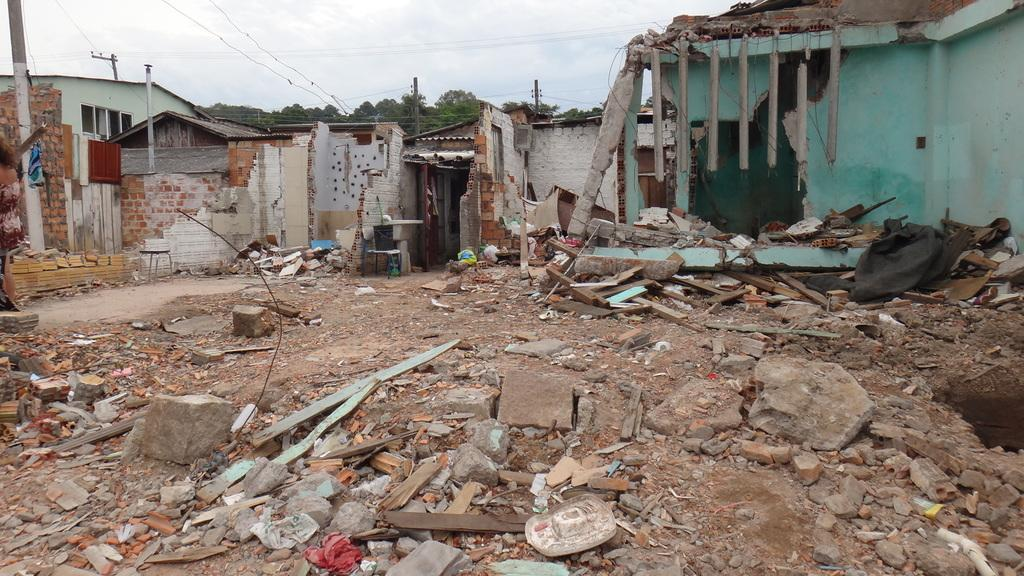What type of structures can be seen in the image? There are houses in the image. What other objects can be seen in the image besides houses? There are poles, trees, objects, a stool, stones, and wooden sticks in the image. Can you describe the natural elements present in the image? There are trees and stones in the image. What is visible at the top of the image? The sky is visible at the top of the image. What type of ray is emitting light from the stool in the image? There is no ray emitting light from the stool in the image. What kind of apparatus can be seen attached to the trees in the image? There is no apparatus attached to the trees in the image. 